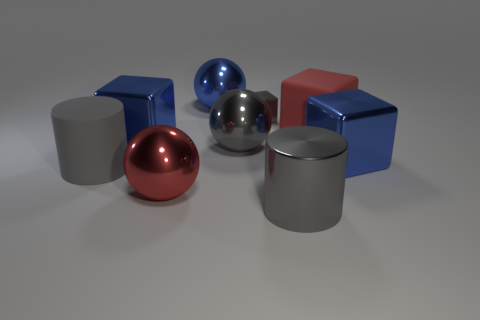The matte thing that is the same color as the tiny shiny cube is what size?
Give a very brief answer. Large. Do the large matte thing on the left side of the large gray metallic cylinder and the tiny thing have the same color?
Keep it short and to the point. Yes. Do the rubber cylinder and the gray cube have the same size?
Make the answer very short. No. What is the shape of the large red object that is the same material as the big gray ball?
Keep it short and to the point. Sphere. What number of other things are there of the same shape as the large red rubber object?
Ensure brevity in your answer.  3. What shape is the blue thing behind the red cube to the right of the large gray shiny cylinder that is in front of the red matte thing?
Ensure brevity in your answer.  Sphere. How many spheres are large gray objects or large red shiny things?
Keep it short and to the point. 2. There is a blue metallic cube that is right of the large gray shiny ball; are there any red rubber things that are right of it?
Make the answer very short. No. There is a red matte thing; is it the same shape as the tiny gray metal object behind the gray matte cylinder?
Your response must be concise. Yes. How many other objects are the same size as the red matte cube?
Ensure brevity in your answer.  7. 